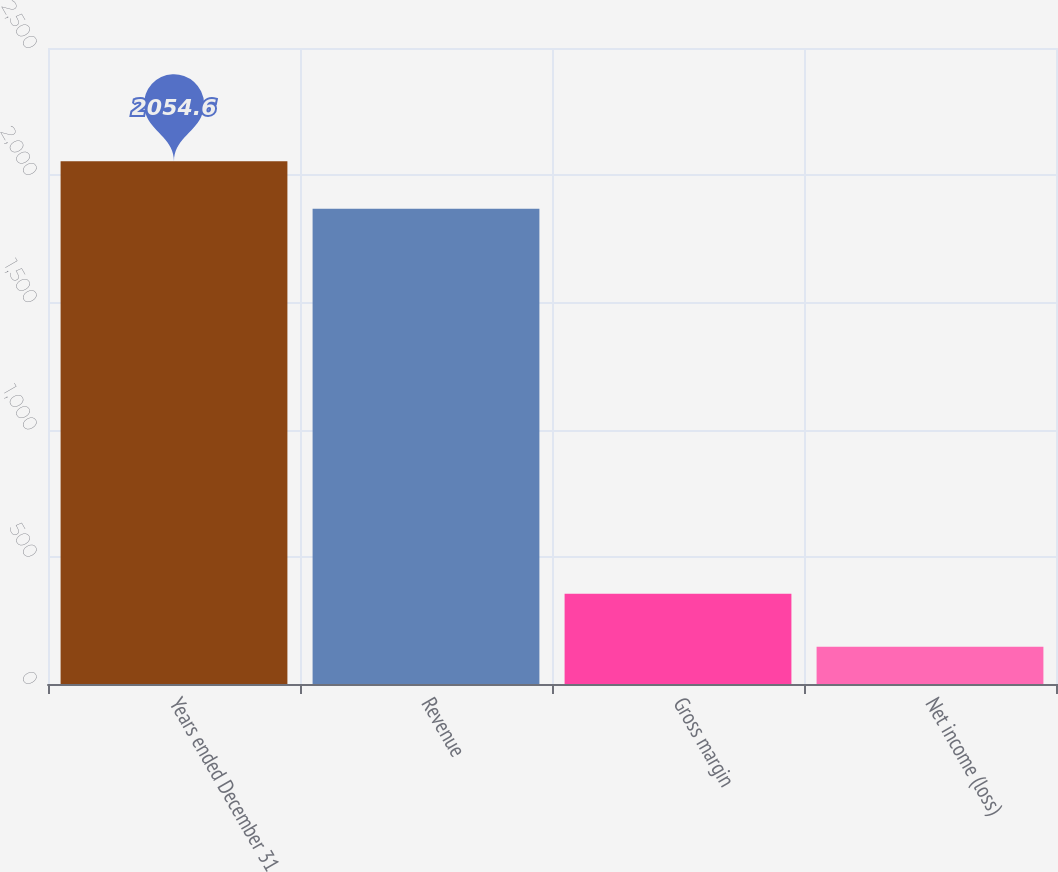Convert chart to OTSL. <chart><loc_0><loc_0><loc_500><loc_500><bar_chart><fcel>Years ended December 31<fcel>Revenue<fcel>Gross margin<fcel>Net income (loss)<nl><fcel>2054.6<fcel>1868<fcel>355<fcel>146<nl></chart> 